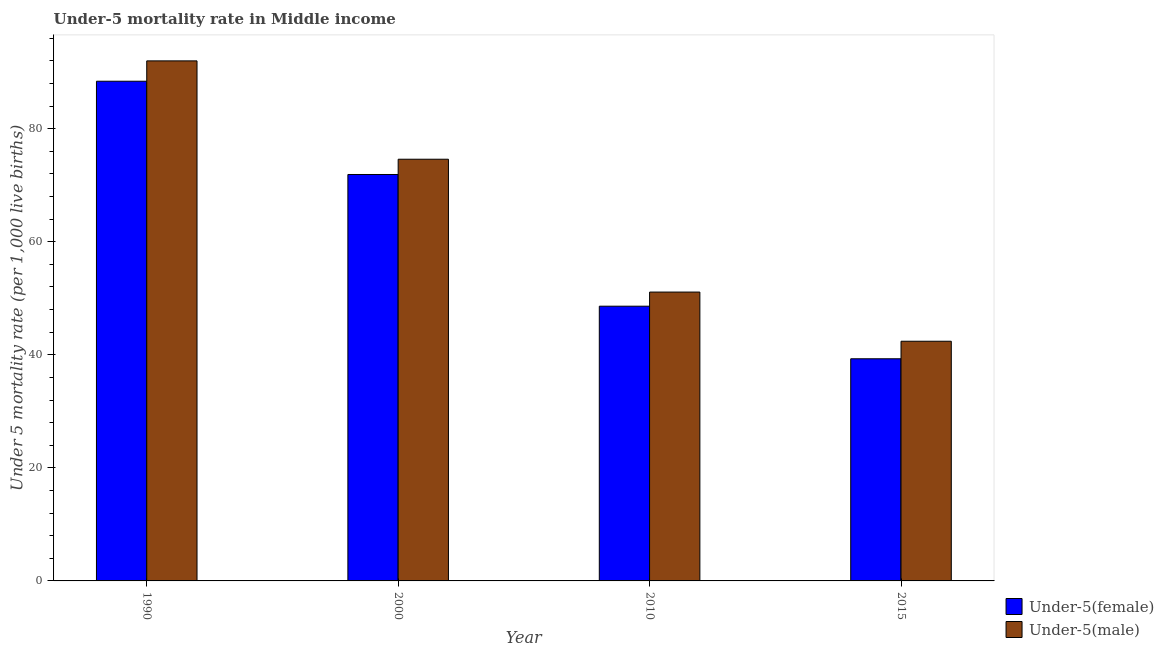How many groups of bars are there?
Provide a short and direct response. 4. How many bars are there on the 3rd tick from the right?
Give a very brief answer. 2. What is the label of the 4th group of bars from the left?
Keep it short and to the point. 2015. In how many cases, is the number of bars for a given year not equal to the number of legend labels?
Your answer should be compact. 0. What is the under-5 male mortality rate in 2015?
Offer a very short reply. 42.4. Across all years, what is the maximum under-5 female mortality rate?
Ensure brevity in your answer.  88.4. Across all years, what is the minimum under-5 male mortality rate?
Your response must be concise. 42.4. In which year was the under-5 male mortality rate maximum?
Your response must be concise. 1990. In which year was the under-5 male mortality rate minimum?
Your answer should be very brief. 2015. What is the total under-5 female mortality rate in the graph?
Offer a very short reply. 248.2. What is the difference between the under-5 male mortality rate in 2010 and that in 2015?
Offer a very short reply. 8.7. What is the difference between the under-5 female mortality rate in 2015 and the under-5 male mortality rate in 1990?
Your answer should be compact. -49.1. What is the average under-5 female mortality rate per year?
Make the answer very short. 62.05. What is the ratio of the under-5 female mortality rate in 2000 to that in 2015?
Your answer should be very brief. 1.83. Is the under-5 male mortality rate in 1990 less than that in 2015?
Keep it short and to the point. No. What is the difference between the highest and the second highest under-5 male mortality rate?
Offer a very short reply. 17.4. What is the difference between the highest and the lowest under-5 male mortality rate?
Ensure brevity in your answer.  49.6. In how many years, is the under-5 male mortality rate greater than the average under-5 male mortality rate taken over all years?
Keep it short and to the point. 2. Is the sum of the under-5 female mortality rate in 1990 and 2010 greater than the maximum under-5 male mortality rate across all years?
Provide a succinct answer. Yes. What does the 1st bar from the left in 1990 represents?
Ensure brevity in your answer.  Under-5(female). What does the 2nd bar from the right in 2000 represents?
Provide a short and direct response. Under-5(female). How many bars are there?
Offer a very short reply. 8. How many years are there in the graph?
Your answer should be compact. 4. What is the difference between two consecutive major ticks on the Y-axis?
Make the answer very short. 20. Are the values on the major ticks of Y-axis written in scientific E-notation?
Your response must be concise. No. Where does the legend appear in the graph?
Provide a succinct answer. Bottom right. How are the legend labels stacked?
Your response must be concise. Vertical. What is the title of the graph?
Give a very brief answer. Under-5 mortality rate in Middle income. Does "Technicians" appear as one of the legend labels in the graph?
Keep it short and to the point. No. What is the label or title of the X-axis?
Your response must be concise. Year. What is the label or title of the Y-axis?
Your answer should be very brief. Under 5 mortality rate (per 1,0 live births). What is the Under 5 mortality rate (per 1,000 live births) of Under-5(female) in 1990?
Keep it short and to the point. 88.4. What is the Under 5 mortality rate (per 1,000 live births) of Under-5(male) in 1990?
Your answer should be very brief. 92. What is the Under 5 mortality rate (per 1,000 live births) of Under-5(female) in 2000?
Give a very brief answer. 71.9. What is the Under 5 mortality rate (per 1,000 live births) in Under-5(male) in 2000?
Give a very brief answer. 74.6. What is the Under 5 mortality rate (per 1,000 live births) in Under-5(female) in 2010?
Your response must be concise. 48.6. What is the Under 5 mortality rate (per 1,000 live births) of Under-5(male) in 2010?
Offer a terse response. 51.1. What is the Under 5 mortality rate (per 1,000 live births) of Under-5(female) in 2015?
Your answer should be compact. 39.3. What is the Under 5 mortality rate (per 1,000 live births) of Under-5(male) in 2015?
Your response must be concise. 42.4. Across all years, what is the maximum Under 5 mortality rate (per 1,000 live births) in Under-5(female)?
Your answer should be very brief. 88.4. Across all years, what is the maximum Under 5 mortality rate (per 1,000 live births) in Under-5(male)?
Your response must be concise. 92. Across all years, what is the minimum Under 5 mortality rate (per 1,000 live births) of Under-5(female)?
Keep it short and to the point. 39.3. Across all years, what is the minimum Under 5 mortality rate (per 1,000 live births) in Under-5(male)?
Provide a succinct answer. 42.4. What is the total Under 5 mortality rate (per 1,000 live births) in Under-5(female) in the graph?
Offer a very short reply. 248.2. What is the total Under 5 mortality rate (per 1,000 live births) in Under-5(male) in the graph?
Offer a terse response. 260.1. What is the difference between the Under 5 mortality rate (per 1,000 live births) of Under-5(male) in 1990 and that in 2000?
Your response must be concise. 17.4. What is the difference between the Under 5 mortality rate (per 1,000 live births) of Under-5(female) in 1990 and that in 2010?
Your response must be concise. 39.8. What is the difference between the Under 5 mortality rate (per 1,000 live births) in Under-5(male) in 1990 and that in 2010?
Your answer should be very brief. 40.9. What is the difference between the Under 5 mortality rate (per 1,000 live births) in Under-5(female) in 1990 and that in 2015?
Your answer should be compact. 49.1. What is the difference between the Under 5 mortality rate (per 1,000 live births) of Under-5(male) in 1990 and that in 2015?
Make the answer very short. 49.6. What is the difference between the Under 5 mortality rate (per 1,000 live births) of Under-5(female) in 2000 and that in 2010?
Keep it short and to the point. 23.3. What is the difference between the Under 5 mortality rate (per 1,000 live births) in Under-5(female) in 2000 and that in 2015?
Your answer should be compact. 32.6. What is the difference between the Under 5 mortality rate (per 1,000 live births) of Under-5(male) in 2000 and that in 2015?
Keep it short and to the point. 32.2. What is the difference between the Under 5 mortality rate (per 1,000 live births) of Under-5(female) in 2010 and that in 2015?
Your answer should be very brief. 9.3. What is the difference between the Under 5 mortality rate (per 1,000 live births) of Under-5(female) in 1990 and the Under 5 mortality rate (per 1,000 live births) of Under-5(male) in 2010?
Provide a short and direct response. 37.3. What is the difference between the Under 5 mortality rate (per 1,000 live births) of Under-5(female) in 1990 and the Under 5 mortality rate (per 1,000 live births) of Under-5(male) in 2015?
Provide a short and direct response. 46. What is the difference between the Under 5 mortality rate (per 1,000 live births) in Under-5(female) in 2000 and the Under 5 mortality rate (per 1,000 live births) in Under-5(male) in 2010?
Provide a short and direct response. 20.8. What is the difference between the Under 5 mortality rate (per 1,000 live births) of Under-5(female) in 2000 and the Under 5 mortality rate (per 1,000 live births) of Under-5(male) in 2015?
Give a very brief answer. 29.5. What is the average Under 5 mortality rate (per 1,000 live births) in Under-5(female) per year?
Your answer should be very brief. 62.05. What is the average Under 5 mortality rate (per 1,000 live births) in Under-5(male) per year?
Provide a short and direct response. 65.03. In the year 1990, what is the difference between the Under 5 mortality rate (per 1,000 live births) in Under-5(female) and Under 5 mortality rate (per 1,000 live births) in Under-5(male)?
Make the answer very short. -3.6. In the year 2000, what is the difference between the Under 5 mortality rate (per 1,000 live births) of Under-5(female) and Under 5 mortality rate (per 1,000 live births) of Under-5(male)?
Your response must be concise. -2.7. In the year 2010, what is the difference between the Under 5 mortality rate (per 1,000 live births) of Under-5(female) and Under 5 mortality rate (per 1,000 live births) of Under-5(male)?
Your answer should be compact. -2.5. In the year 2015, what is the difference between the Under 5 mortality rate (per 1,000 live births) in Under-5(female) and Under 5 mortality rate (per 1,000 live births) in Under-5(male)?
Provide a short and direct response. -3.1. What is the ratio of the Under 5 mortality rate (per 1,000 live births) of Under-5(female) in 1990 to that in 2000?
Your answer should be compact. 1.23. What is the ratio of the Under 5 mortality rate (per 1,000 live births) of Under-5(male) in 1990 to that in 2000?
Your answer should be compact. 1.23. What is the ratio of the Under 5 mortality rate (per 1,000 live births) of Under-5(female) in 1990 to that in 2010?
Offer a terse response. 1.82. What is the ratio of the Under 5 mortality rate (per 1,000 live births) of Under-5(male) in 1990 to that in 2010?
Provide a short and direct response. 1.8. What is the ratio of the Under 5 mortality rate (per 1,000 live births) in Under-5(female) in 1990 to that in 2015?
Offer a terse response. 2.25. What is the ratio of the Under 5 mortality rate (per 1,000 live births) of Under-5(male) in 1990 to that in 2015?
Give a very brief answer. 2.17. What is the ratio of the Under 5 mortality rate (per 1,000 live births) in Under-5(female) in 2000 to that in 2010?
Your response must be concise. 1.48. What is the ratio of the Under 5 mortality rate (per 1,000 live births) in Under-5(male) in 2000 to that in 2010?
Your answer should be compact. 1.46. What is the ratio of the Under 5 mortality rate (per 1,000 live births) of Under-5(female) in 2000 to that in 2015?
Your answer should be compact. 1.83. What is the ratio of the Under 5 mortality rate (per 1,000 live births) of Under-5(male) in 2000 to that in 2015?
Keep it short and to the point. 1.76. What is the ratio of the Under 5 mortality rate (per 1,000 live births) in Under-5(female) in 2010 to that in 2015?
Keep it short and to the point. 1.24. What is the ratio of the Under 5 mortality rate (per 1,000 live births) of Under-5(male) in 2010 to that in 2015?
Offer a very short reply. 1.21. What is the difference between the highest and the second highest Under 5 mortality rate (per 1,000 live births) in Under-5(female)?
Ensure brevity in your answer.  16.5. What is the difference between the highest and the lowest Under 5 mortality rate (per 1,000 live births) of Under-5(female)?
Offer a terse response. 49.1. What is the difference between the highest and the lowest Under 5 mortality rate (per 1,000 live births) of Under-5(male)?
Your answer should be very brief. 49.6. 